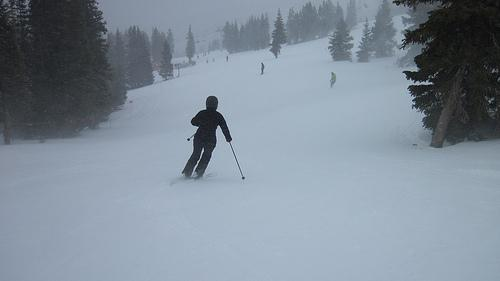Question: what is next to the lady?
Choices:
A. A dog.
B. A child.
C. Cars.
D. Trees.
Answer with the letter. Answer: D Question: where was the photo taken?
Choices:
A. Baseball field.
B. Tennis court.
C. Stadium.
D. Ski slope.
Answer with the letter. Answer: D 